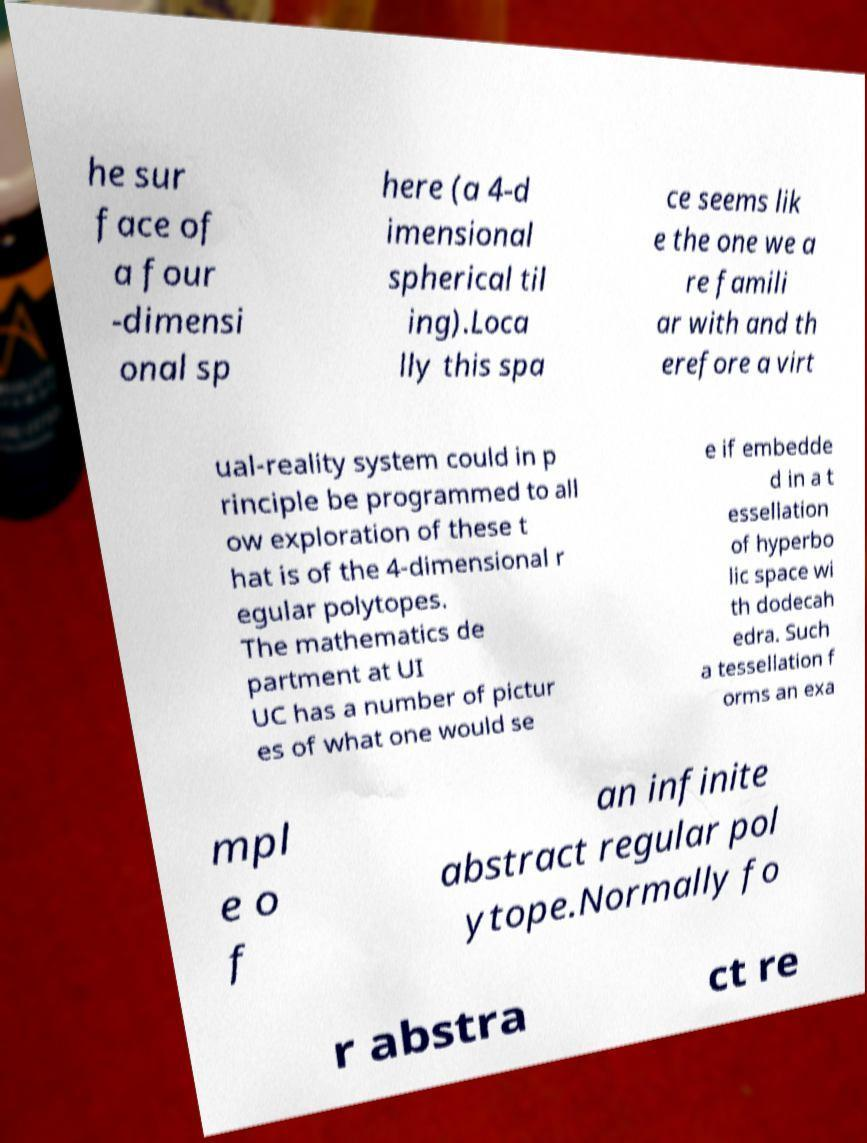Could you extract and type out the text from this image? he sur face of a four -dimensi onal sp here (a 4-d imensional spherical til ing).Loca lly this spa ce seems lik e the one we a re famili ar with and th erefore a virt ual-reality system could in p rinciple be programmed to all ow exploration of these t hat is of the 4-dimensional r egular polytopes. The mathematics de partment at UI UC has a number of pictur es of what one would se e if embedde d in a t essellation of hyperbo lic space wi th dodecah edra. Such a tessellation f orms an exa mpl e o f an infinite abstract regular pol ytope.Normally fo r abstra ct re 